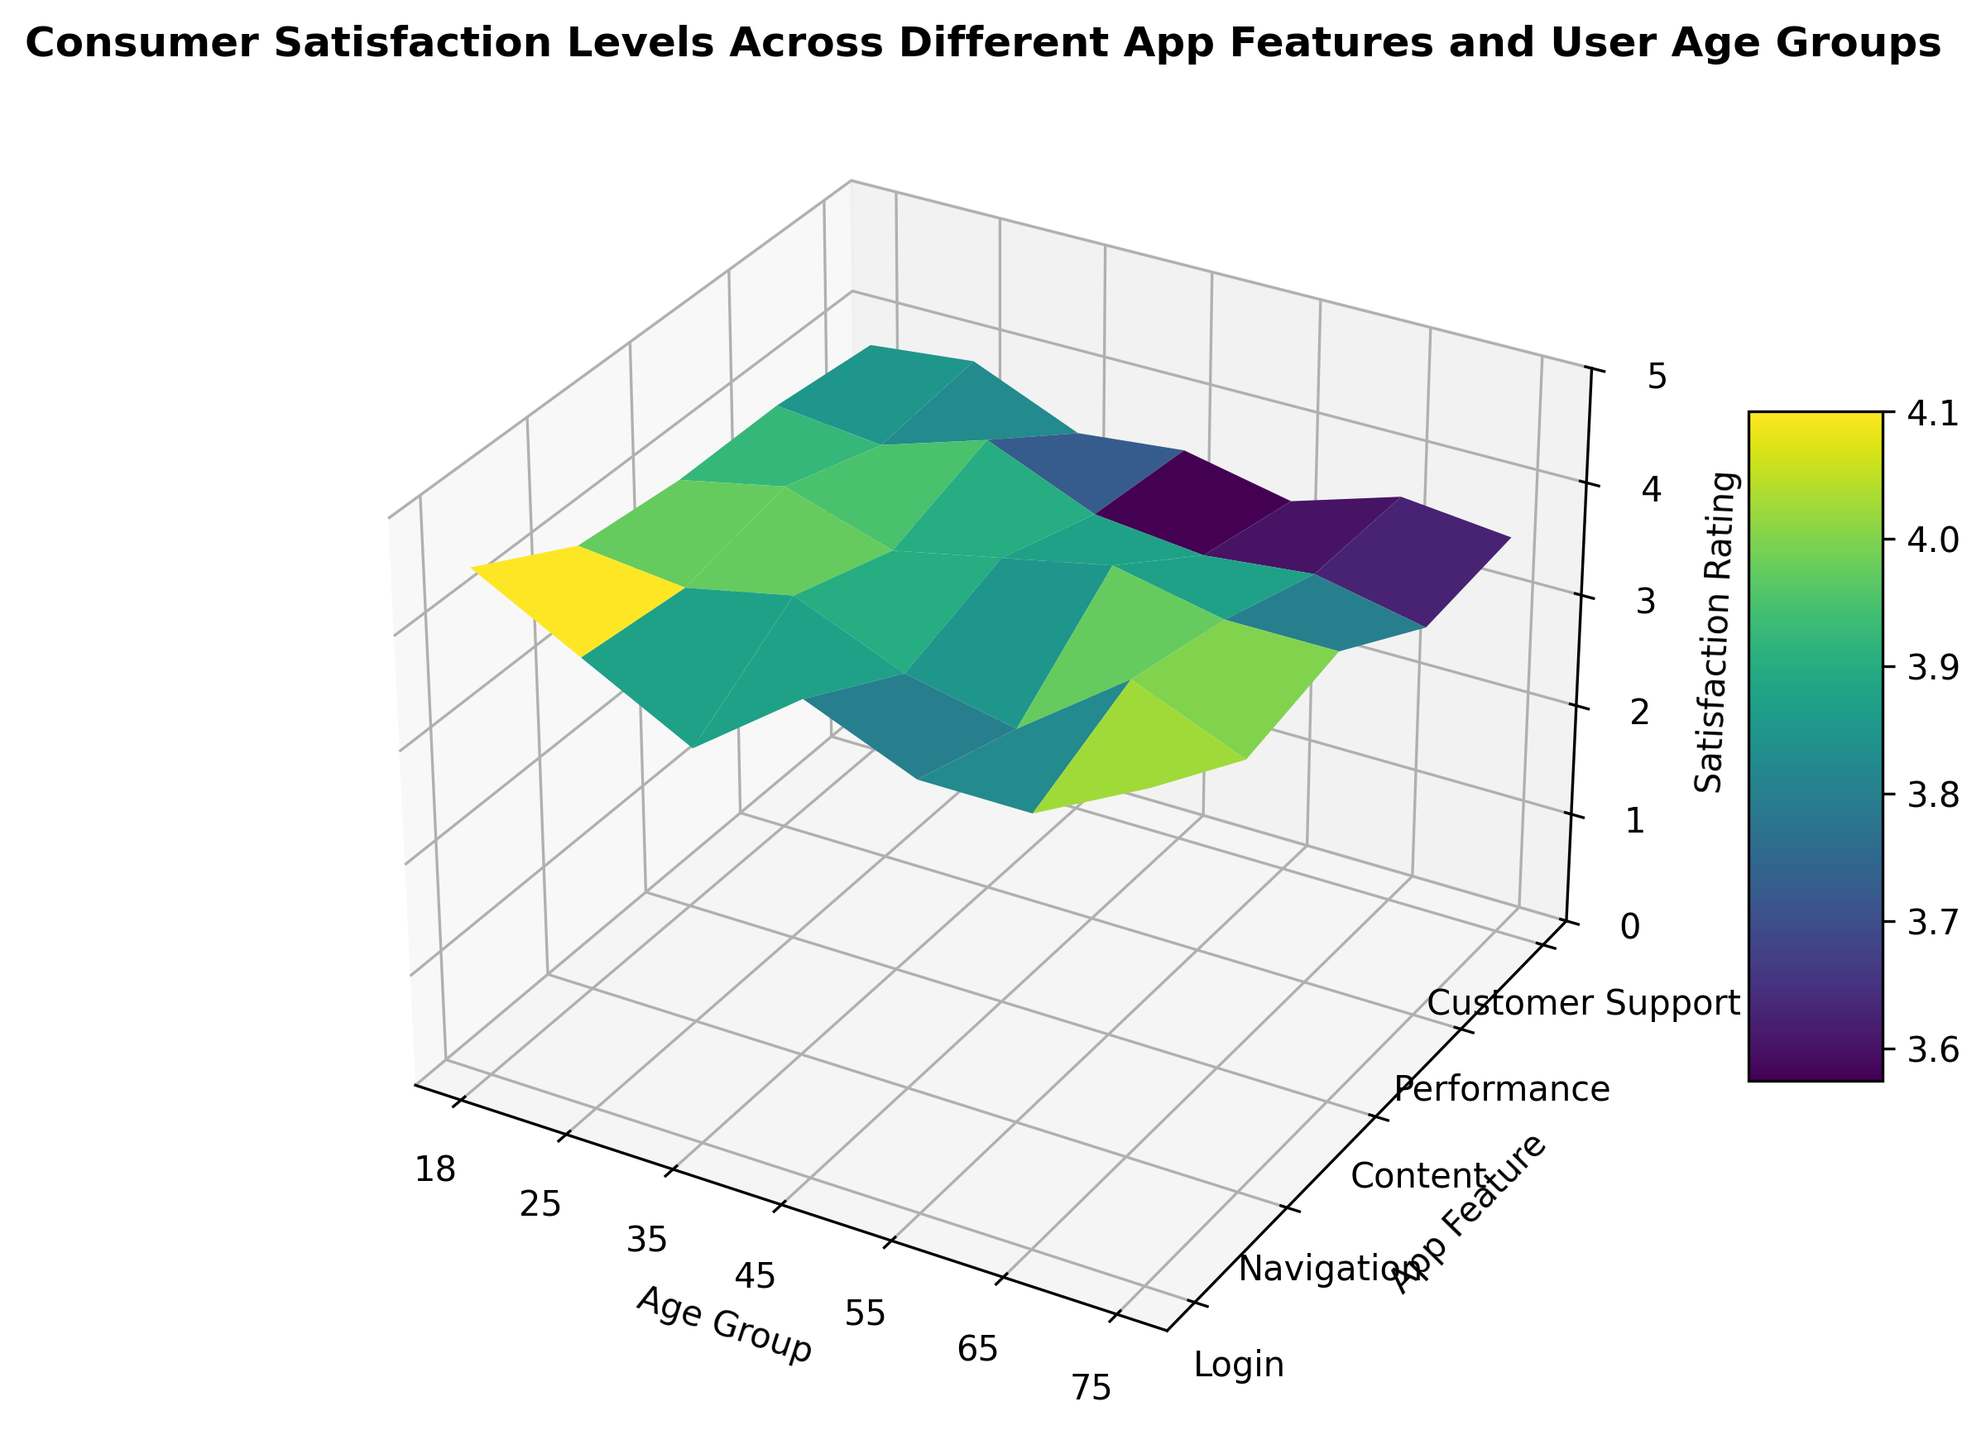What is the overall trend in satisfaction ratings for the 'Login' feature across different age groups? To identify the trend, observe the z-axis values (satisfaction ratings) for 'Login' across the x-axis (age groups). The ratings decrease from age 18 to around age 35, increase slightly in middle ages, and decrease again for older groups.
Answer: Decreasing then increasing Which age group has the highest satisfaction rating for 'Performance'? Locate the bar representing 'Performance' and compare z-axis values across all age groups. The highest satisfaction rating for 'Performance' is observed for age 18 and 45.
Answer: Age 18 and 45 How does the satisfaction rating for 'Customer Support' compare between age 25 and age 75? Compare the heights of the bars for 'Customer Support' at age 25 and age 75. The rating for age 25 is higher than that for age 75.
Answer: Higher at age 25 If you average the satisfaction ratings for the 'Content' feature across all age groups, what is the value? Sum the ratings for 'Content' across all age groups (3.5, 4.0, 4.2, 4.0, 3.8, 3.5, 3.4) and divide by the number of age groups (7). The average rating is (3.5 + 4.0 + 4.2 + 4.0 + 3.8 + 3.5 + 3.4) / 7 = 26.4 / 7 = 3.77.
Answer: 3.77 Which app feature tends to have the lowest satisfaction ratings across all age groups? Observe the z-axis (satisfaction ratings) for all features across all age groups. 'Navigation' and 'Content' have relatively lower ratings, with 'Content' often at the lower end.
Answer: Content Among the older age groups (55, 65, 75), which age group shows a significant drop in satisfaction rating for 'Navigation' compared to younger age groups? Compare the 'Navigation' ratings across age groups. Notice that ages 65 and 75 have significant drops compared to younger groups.
Answer: 65 and 75 Between which age groups is the biggest change in satisfaction rating observed for 'Navigation'? Identify the peaks and valleys in the 'Navigation' ratings and compare differences between adjacent age groups. The largest change is observed between age 25 and age 35.
Answer: Age 25 and 35 Is there any app feature that maintains a consistent satisfaction rating regardless of age group? Observe each feature's satisfaction ratings across all age groups. 'Performance' has relatively small changes in satisfaction ratings across different age groups.
Answer: Performance 